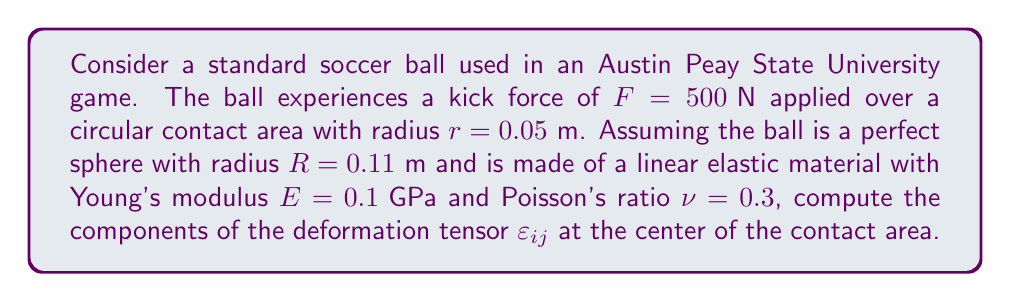Teach me how to tackle this problem. To solve this problem, we'll follow these steps:

1) First, we need to calculate the stress at the center of the contact area. For a circular contact area, the stress is given by:

   $$\sigma = \frac{F}{\pi r^2}$$

   Substituting the values:
   $$\sigma = \frac{500}{\pi (0.05)^2} = 63.66 \times 10^6 \text{ Pa}$$

2) For a linear elastic material, the stress-strain relationship is given by Hooke's law:

   $$\varepsilon_{ij} = \frac{1+\nu}{E}\sigma_{ij} - \frac{\nu}{E}\sigma_{kk}\delta_{ij}$$

   Where $\sigma_{kk}$ is the trace of the stress tensor, and $\delta_{ij}$ is the Kronecker delta.

3) In our case, we have a uniaxial stress state, so:

   $$\sigma_{11} = \sigma_{22} = 0, \sigma_{33} = \sigma = 63.66 \times 10^6 \text{ Pa}$$
   $$\sigma_{kk} = \sigma_{33} = 63.66 \times 10^6 \text{ Pa}$$

4) Now we can calculate each component of the deformation tensor:

   For $i = j = 1$ or $i = j = 2$:
   $$\varepsilon_{11} = \varepsilon_{22} = -\frac{\nu}{E}\sigma = -\frac{0.3}{0.1 \times 10^9} \times 63.66 \times 10^6 = -0.01910$$

   For $i = j = 3$:
   $$\varepsilon_{33} = \frac{1+\nu}{E}\sigma - \frac{\nu}{E}\sigma = \frac{1}{E}\sigma = \frac{1}{0.1 \times 10^9} \times 63.66 \times 10^6 = 0.6366$$

   For $i \neq j$:
   $$\varepsilon_{ij} = 0$$

5) Therefore, the deformation tensor is:

   $$\varepsilon_{ij} = \begin{pmatrix}
   -0.01910 & 0 & 0 \\
   0 & -0.01910 & 0 \\
   0 & 0 & 0.6366
   \end{pmatrix}$$
Answer: $$\varepsilon_{ij} = \begin{pmatrix}
-0.01910 & 0 & 0 \\
0 & -0.01910 & 0 \\
0 & 0 & 0.6366
\end{pmatrix}$$ 